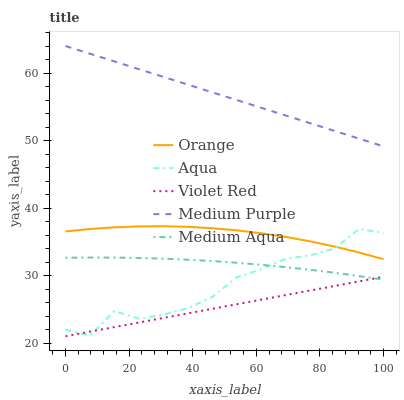Does Violet Red have the minimum area under the curve?
Answer yes or no. Yes. Does Medium Purple have the maximum area under the curve?
Answer yes or no. Yes. Does Medium Purple have the minimum area under the curve?
Answer yes or no. No. Does Violet Red have the maximum area under the curve?
Answer yes or no. No. Is Violet Red the smoothest?
Answer yes or no. Yes. Is Aqua the roughest?
Answer yes or no. Yes. Is Medium Purple the smoothest?
Answer yes or no. No. Is Medium Purple the roughest?
Answer yes or no. No. Does Violet Red have the lowest value?
Answer yes or no. Yes. Does Medium Purple have the lowest value?
Answer yes or no. No. Does Medium Purple have the highest value?
Answer yes or no. Yes. Does Violet Red have the highest value?
Answer yes or no. No. Is Violet Red less than Orange?
Answer yes or no. Yes. Is Medium Purple greater than Violet Red?
Answer yes or no. Yes. Does Violet Red intersect Medium Aqua?
Answer yes or no. Yes. Is Violet Red less than Medium Aqua?
Answer yes or no. No. Is Violet Red greater than Medium Aqua?
Answer yes or no. No. Does Violet Red intersect Orange?
Answer yes or no. No. 